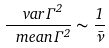<formula> <loc_0><loc_0><loc_500><loc_500>\frac { \ v a r { \Gamma ^ { 2 } } } { \ m e a n { \Gamma } ^ { 2 } } \sim \frac { 1 } { \bar { \nu } }</formula> 